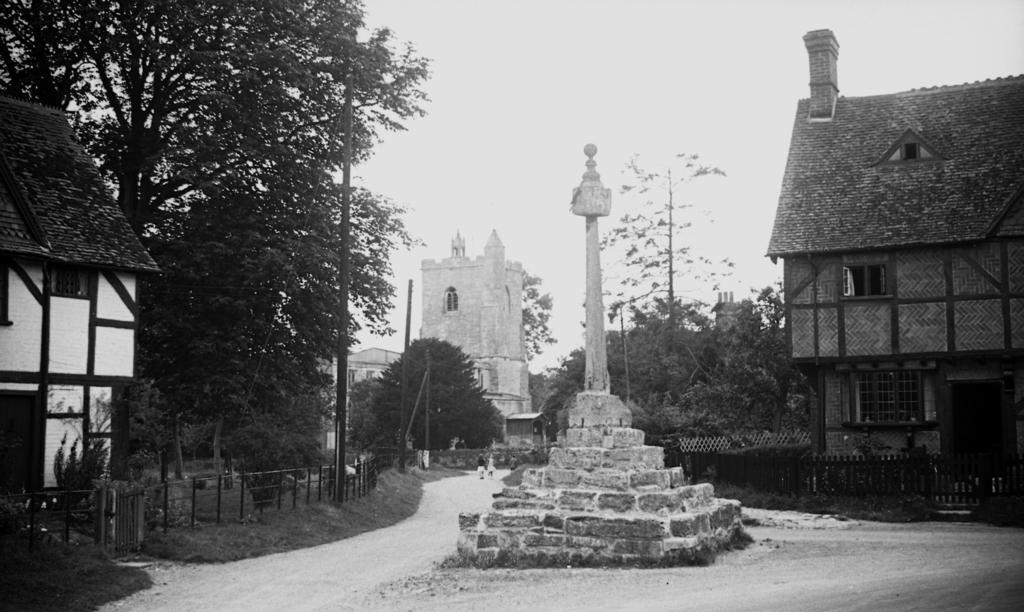In one or two sentences, can you explain what this image depicts? It looks like a black and white image. I can see the buildings with the windows. It looks like a pillar. On the left side of the image, I can see the fence and a small gate. These are the trees. It looks like a pathway. At the top of the image, I think this is the sky. On the right side of the image, I can see a wooden fence, which is in front of a building. 